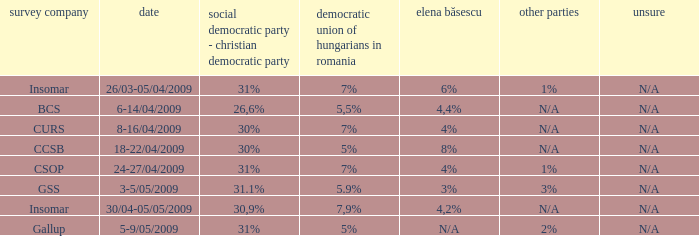What was the UDMR for 18-22/04/2009? 5%. 